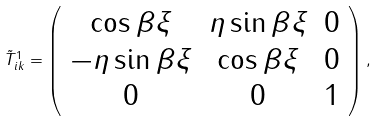Convert formula to latex. <formula><loc_0><loc_0><loc_500><loc_500>\tilde { T } ^ { 1 } _ { i k } = \left ( \begin{array} { c c c } \cos \beta \xi & \eta \sin \beta \xi & 0 \\ - \eta \sin \beta \xi & \cos \beta \xi & 0 \\ 0 & 0 & 1 \\ \end{array} \right ) ,</formula> 